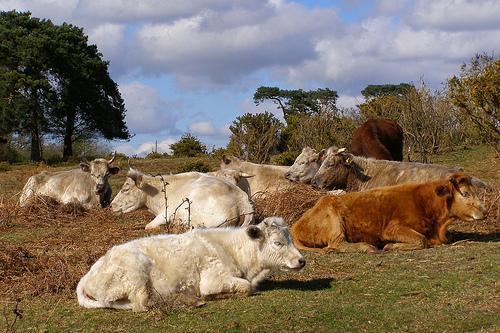How many cows are there?
Give a very brief answer. 7. 